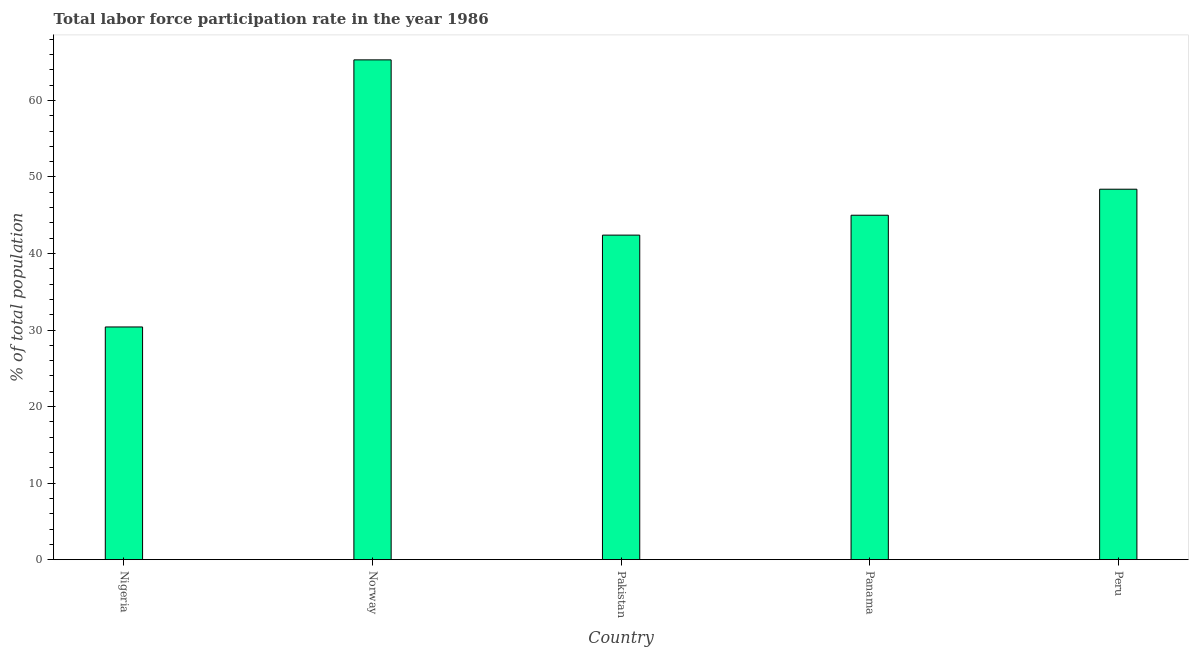Does the graph contain grids?
Give a very brief answer. No. What is the title of the graph?
Give a very brief answer. Total labor force participation rate in the year 1986. What is the label or title of the X-axis?
Provide a succinct answer. Country. What is the label or title of the Y-axis?
Offer a terse response. % of total population. What is the total labor force participation rate in Norway?
Your answer should be compact. 65.3. Across all countries, what is the maximum total labor force participation rate?
Offer a very short reply. 65.3. Across all countries, what is the minimum total labor force participation rate?
Your answer should be very brief. 30.4. In which country was the total labor force participation rate maximum?
Offer a terse response. Norway. In which country was the total labor force participation rate minimum?
Provide a short and direct response. Nigeria. What is the sum of the total labor force participation rate?
Your response must be concise. 231.5. What is the average total labor force participation rate per country?
Provide a succinct answer. 46.3. What is the ratio of the total labor force participation rate in Nigeria to that in Peru?
Offer a very short reply. 0.63. Is the total labor force participation rate in Norway less than that in Peru?
Give a very brief answer. No. What is the difference between the highest and the lowest total labor force participation rate?
Provide a succinct answer. 34.9. In how many countries, is the total labor force participation rate greater than the average total labor force participation rate taken over all countries?
Your answer should be very brief. 2. How many countries are there in the graph?
Keep it short and to the point. 5. What is the difference between two consecutive major ticks on the Y-axis?
Make the answer very short. 10. What is the % of total population in Nigeria?
Provide a succinct answer. 30.4. What is the % of total population in Norway?
Make the answer very short. 65.3. What is the % of total population in Pakistan?
Offer a very short reply. 42.4. What is the % of total population of Panama?
Ensure brevity in your answer.  45. What is the % of total population of Peru?
Offer a terse response. 48.4. What is the difference between the % of total population in Nigeria and Norway?
Your response must be concise. -34.9. What is the difference between the % of total population in Nigeria and Panama?
Offer a very short reply. -14.6. What is the difference between the % of total population in Norway and Pakistan?
Your answer should be very brief. 22.9. What is the difference between the % of total population in Norway and Panama?
Make the answer very short. 20.3. What is the difference between the % of total population in Norway and Peru?
Keep it short and to the point. 16.9. What is the difference between the % of total population in Pakistan and Peru?
Offer a very short reply. -6. What is the ratio of the % of total population in Nigeria to that in Norway?
Make the answer very short. 0.47. What is the ratio of the % of total population in Nigeria to that in Pakistan?
Your answer should be compact. 0.72. What is the ratio of the % of total population in Nigeria to that in Panama?
Offer a terse response. 0.68. What is the ratio of the % of total population in Nigeria to that in Peru?
Your answer should be compact. 0.63. What is the ratio of the % of total population in Norway to that in Pakistan?
Your answer should be very brief. 1.54. What is the ratio of the % of total population in Norway to that in Panama?
Provide a short and direct response. 1.45. What is the ratio of the % of total population in Norway to that in Peru?
Your response must be concise. 1.35. What is the ratio of the % of total population in Pakistan to that in Panama?
Your response must be concise. 0.94. What is the ratio of the % of total population in Pakistan to that in Peru?
Make the answer very short. 0.88. 